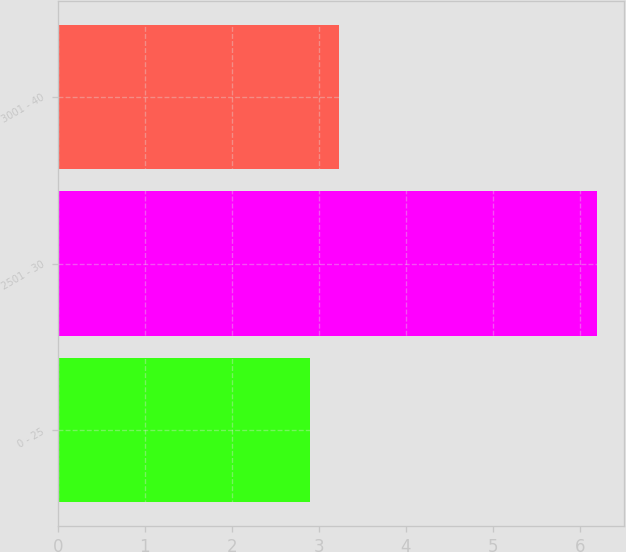<chart> <loc_0><loc_0><loc_500><loc_500><bar_chart><fcel>0 - 25<fcel>2501 - 30<fcel>3001 - 40<nl><fcel>2.9<fcel>6.2<fcel>3.23<nl></chart> 